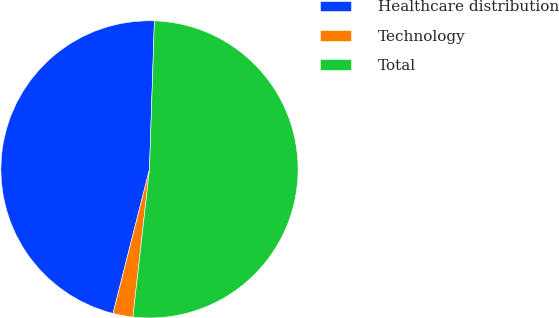<chart> <loc_0><loc_0><loc_500><loc_500><pie_chart><fcel>Healthcare distribution<fcel>Technology<fcel>Total<nl><fcel>46.59%<fcel>2.17%<fcel>51.25%<nl></chart> 